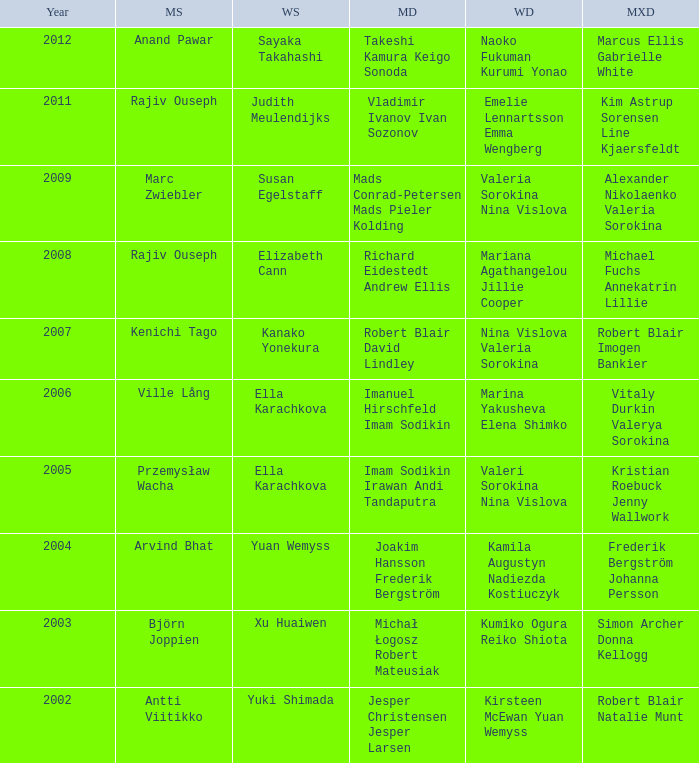What is the mens singles of 2008? Rajiv Ouseph. 